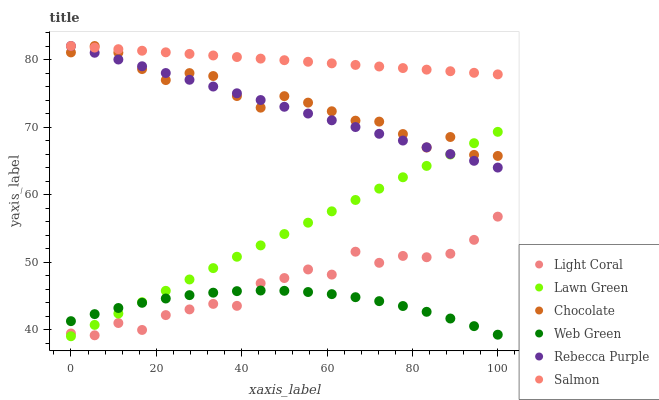Does Web Green have the minimum area under the curve?
Answer yes or no. Yes. Does Salmon have the maximum area under the curve?
Answer yes or no. Yes. Does Salmon have the minimum area under the curve?
Answer yes or no. No. Does Web Green have the maximum area under the curve?
Answer yes or no. No. Is Lawn Green the smoothest?
Answer yes or no. Yes. Is Light Coral the roughest?
Answer yes or no. Yes. Is Salmon the smoothest?
Answer yes or no. No. Is Salmon the roughest?
Answer yes or no. No. Does Lawn Green have the lowest value?
Answer yes or no. Yes. Does Web Green have the lowest value?
Answer yes or no. No. Does Rebecca Purple have the highest value?
Answer yes or no. Yes. Does Web Green have the highest value?
Answer yes or no. No. Is Web Green less than Salmon?
Answer yes or no. Yes. Is Chocolate greater than Web Green?
Answer yes or no. Yes. Does Web Green intersect Light Coral?
Answer yes or no. Yes. Is Web Green less than Light Coral?
Answer yes or no. No. Is Web Green greater than Light Coral?
Answer yes or no. No. Does Web Green intersect Salmon?
Answer yes or no. No. 